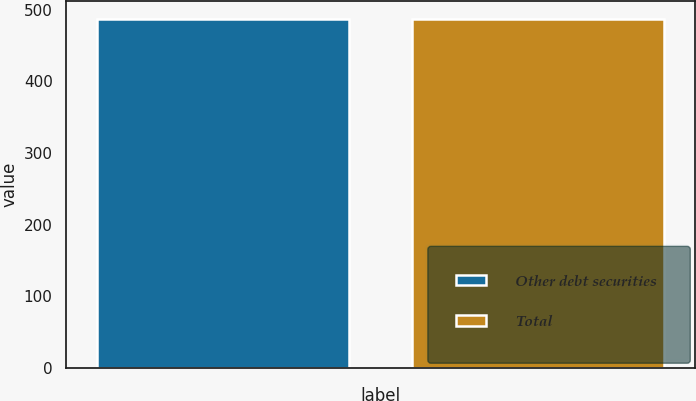Convert chart. <chart><loc_0><loc_0><loc_500><loc_500><bar_chart><fcel>Other debt securities<fcel>Total<nl><fcel>487.3<fcel>487.8<nl></chart> 